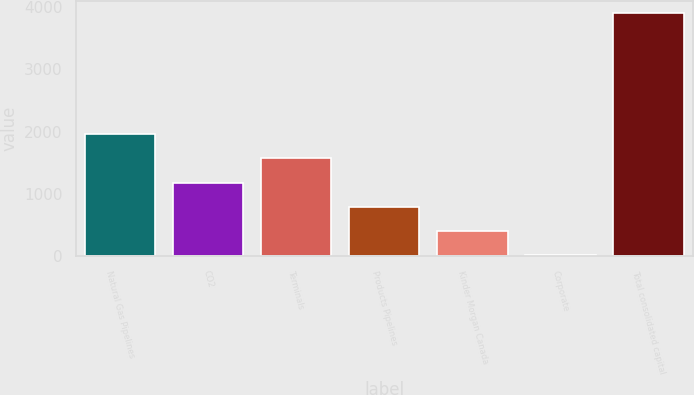<chart> <loc_0><loc_0><loc_500><loc_500><bar_chart><fcel>Natural Gas Pipelines<fcel>CO2<fcel>Terminals<fcel>Products Pipelines<fcel>Kinder Morgan Canada<fcel>Corporate<fcel>Total consolidated capital<nl><fcel>1956<fcel>1180<fcel>1568<fcel>792<fcel>404<fcel>16<fcel>3896<nl></chart> 